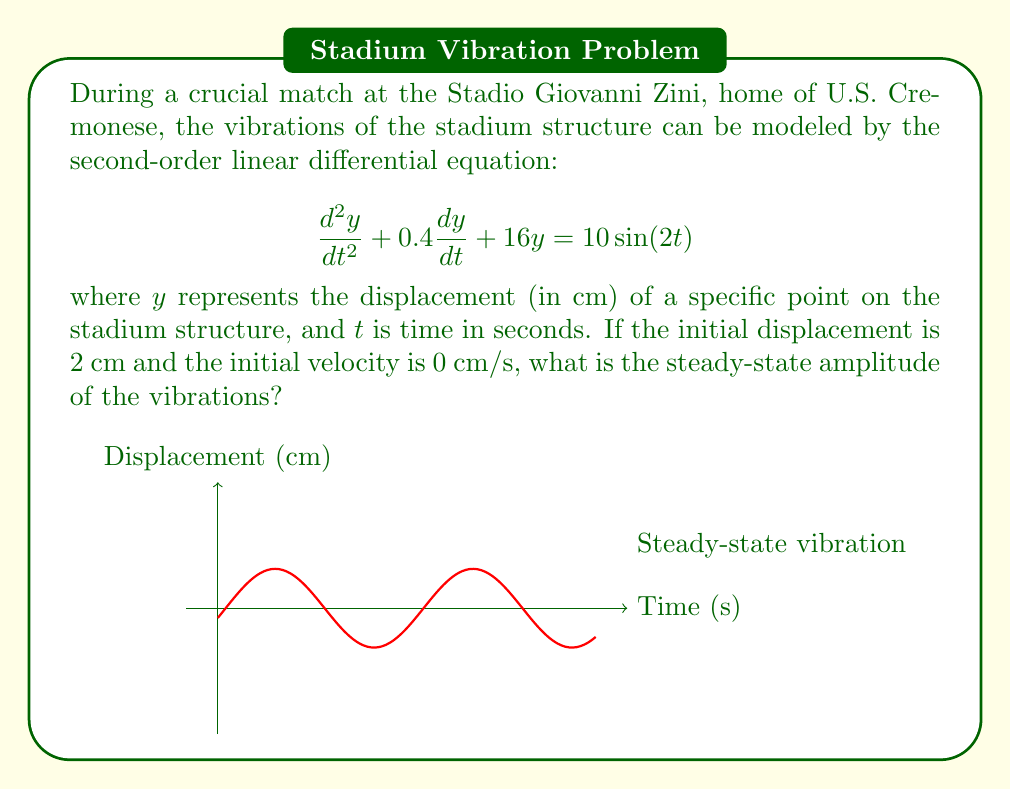What is the answer to this math problem? To find the steady-state amplitude, we follow these steps:

1) The given equation is in the form:
   $$\frac{d^2y}{dt^2} + 2\zeta\omega_n\frac{dy}{dt} + \omega_n^2y = F_0\sin(\omega t)$$

2) Identify the parameters:
   $\omega_n^2 = 16$, so $\omega_n = 4$ rad/s
   $2\zeta\omega_n = 0.4$, so $\zeta = 0.05$
   $F_0 = 10$
   $\omega = 2$ rad/s

3) The steady-state amplitude for a forced vibration is given by:
   $$A = \frac{F_0}{\sqrt{(\omega_n^2 - \omega^2)^2 + (2\zeta\omega_n\omega)^2}}$$

4) Substitute the values:
   $$A = \frac{10}{\sqrt{(16 - 4)^2 + (2 * 0.05 * 4 * 2)^2}}$$

5) Simplify:
   $$A = \frac{10}{\sqrt{144 + 0.64}} = \frac{10}{\sqrt{144.64}} = \frac{10}{12.027}$$

6) Calculate the final result:
   $$A \approx 0.831 \text{ cm}$$

The initial conditions (displacement and velocity) do not affect the steady-state amplitude, only the transient response.
Answer: 0.831 cm 